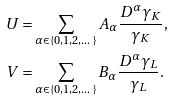Convert formula to latex. <formula><loc_0><loc_0><loc_500><loc_500>U & = \sum _ { \alpha \in \{ 0 , 1 , 2 , \dots \} } A _ { \alpha } \frac { D ^ { \alpha } \gamma _ { K } } { \gamma _ { K } } , \\ V & = \sum _ { \alpha \in \{ 0 , 1 , 2 , \dots \} } B _ { \alpha } \frac { D ^ { \alpha } \gamma _ { L } } { \gamma _ { L } } .</formula> 